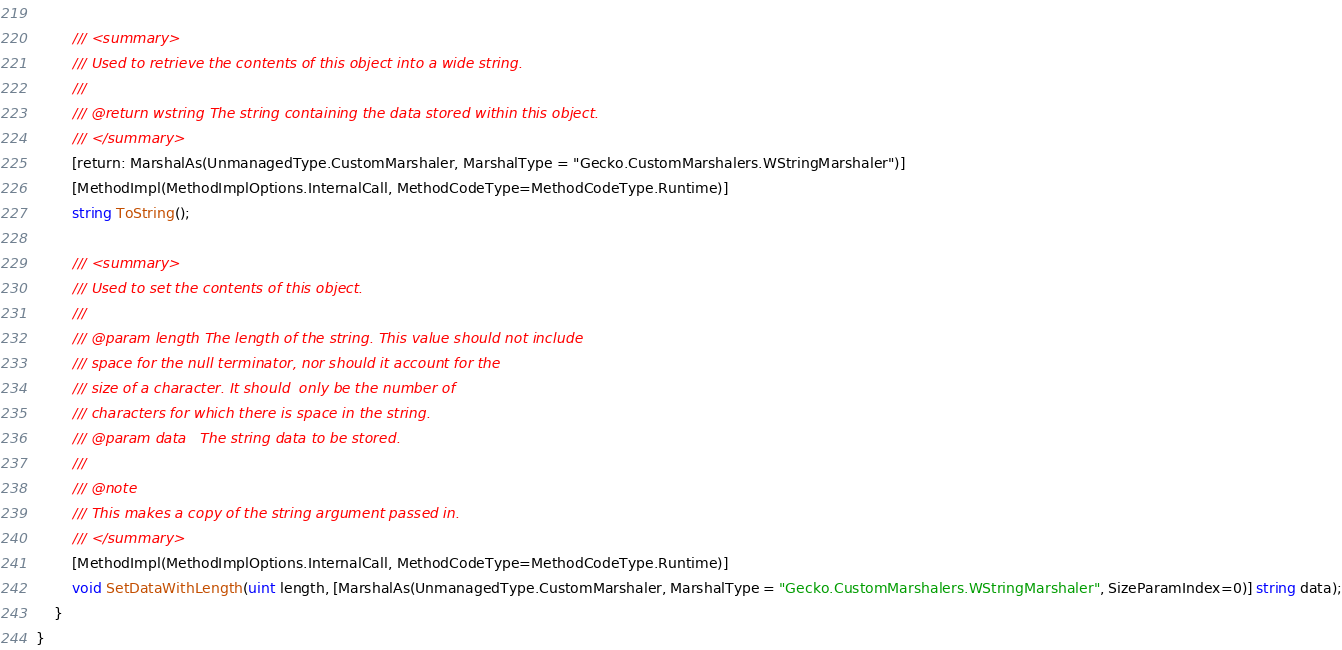<code> <loc_0><loc_0><loc_500><loc_500><_C#_>		
		/// <summary>
        /// Used to retrieve the contents of this object into a wide string.
        ///
        /// @return wstring The string containing the data stored within this object.
        /// </summary>
		[return: MarshalAs(UnmanagedType.CustomMarshaler, MarshalType = "Gecko.CustomMarshalers.WStringMarshaler")]
		[MethodImpl(MethodImplOptions.InternalCall, MethodCodeType=MethodCodeType.Runtime)]
		string ToString();
		
		/// <summary>
        /// Used to set the contents of this object.
        ///
        /// @param length The length of the string. This value should not include
        /// space for the null terminator, nor should it account for the
        /// size of a character. It should  only be the number of
        /// characters for which there is space in the string.
        /// @param data   The string data to be stored.
        ///
        /// @note
        /// This makes a copy of the string argument passed in.
        /// </summary>
		[MethodImpl(MethodImplOptions.InternalCall, MethodCodeType=MethodCodeType.Runtime)]
		void SetDataWithLength(uint length, [MarshalAs(UnmanagedType.CustomMarshaler, MarshalType = "Gecko.CustomMarshalers.WStringMarshaler", SizeParamIndex=0)] string data);
	}
}
</code> 